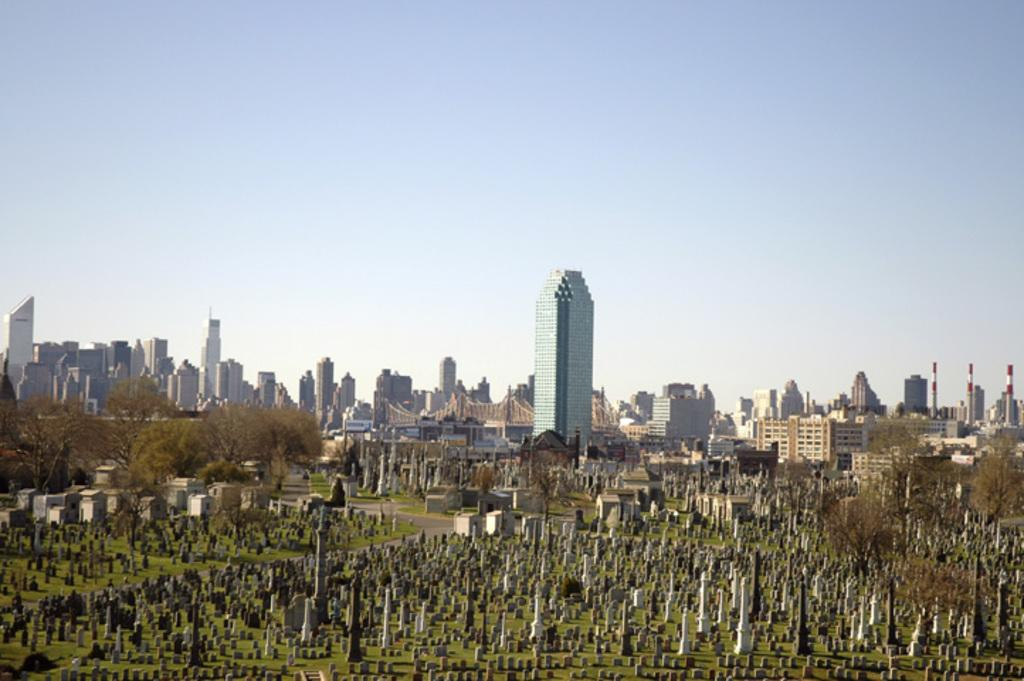What can be seen on the ground in the image? There are graves on the ground in the image. What is visible in the background of the image? There are buildings, trees, and the sky visible in the background of the image. How many snakes are crawling on the graves in the image? There are no snakes present in the image; it only shows graves on the ground. What type of stitch is used to sew the farmer's clothes in the image? There is no farmer or any clothing mentioned in the image; it only features graves, buildings, trees, and the sky. 